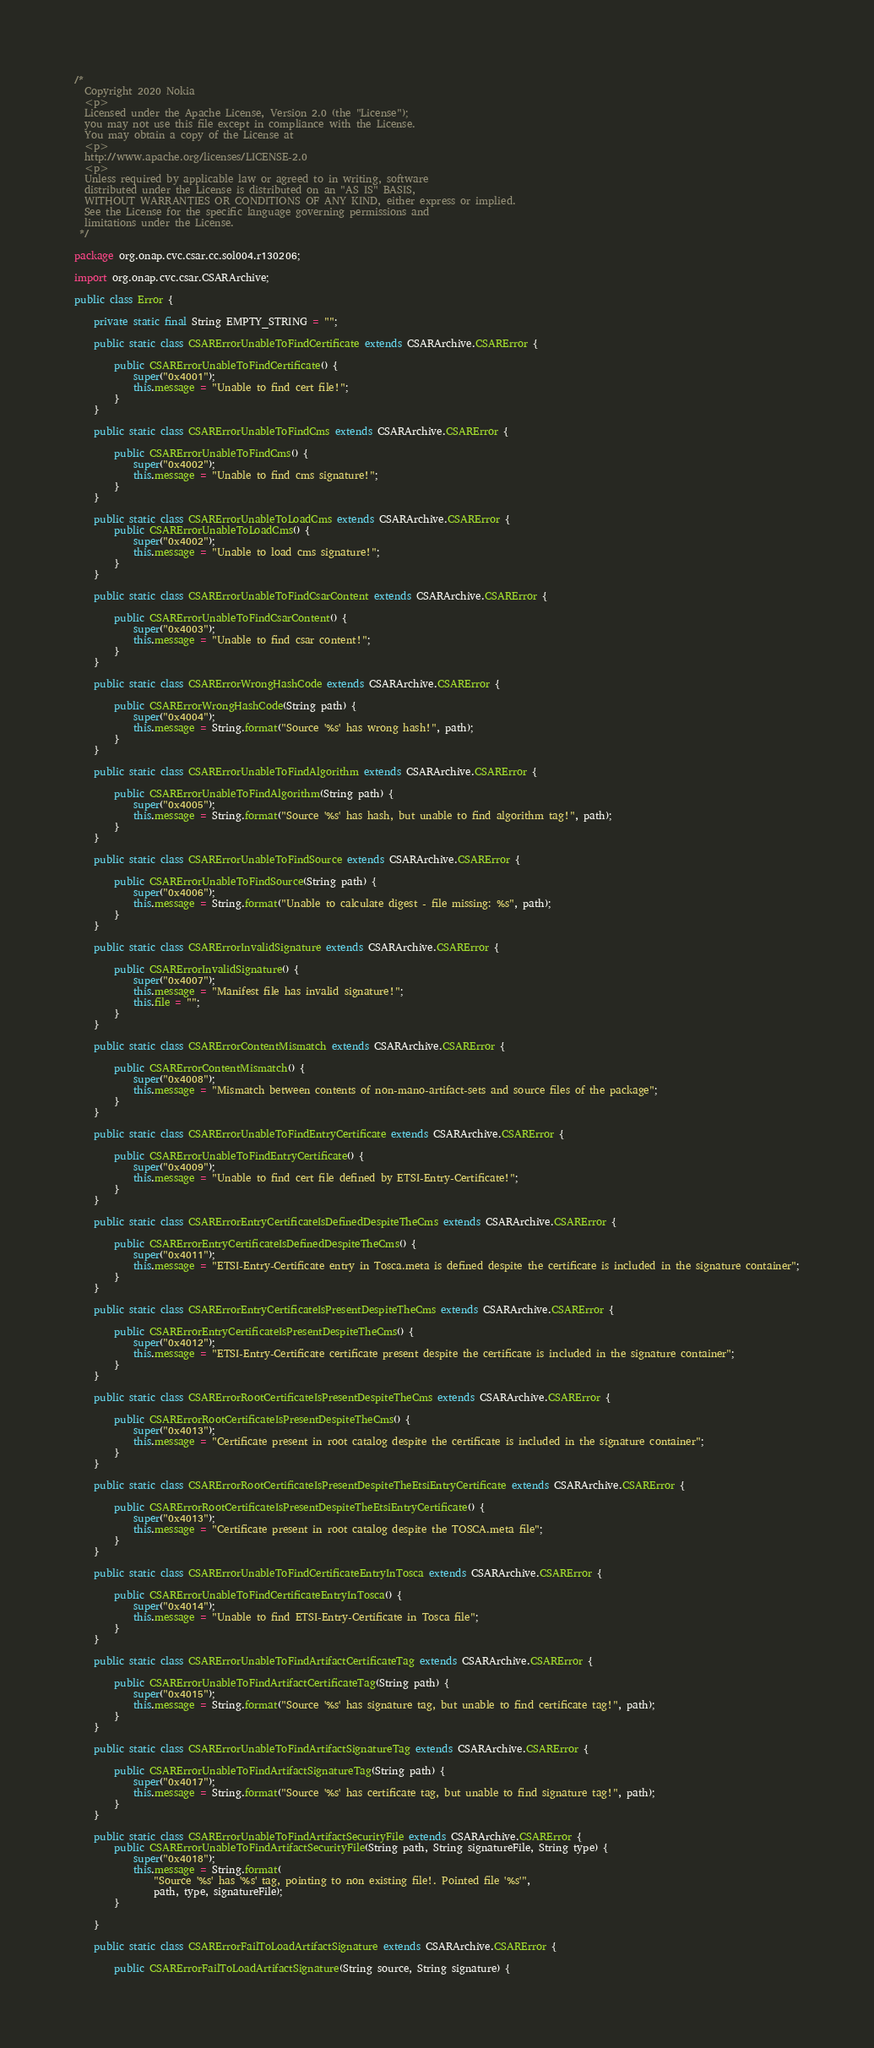<code> <loc_0><loc_0><loc_500><loc_500><_Java_>/*
  Copyright 2020 Nokia
  <p>
  Licensed under the Apache License, Version 2.0 (the "License");
  you may not use this file except in compliance with the License.
  You may obtain a copy of the License at
  <p>
  http://www.apache.org/licenses/LICENSE-2.0
  <p>
  Unless required by applicable law or agreed to in writing, software
  distributed under the License is distributed on an "AS IS" BASIS,
  WITHOUT WARRANTIES OR CONDITIONS OF ANY KIND, either express or implied.
  See the License for the specific language governing permissions and
  limitations under the License.
 */

package org.onap.cvc.csar.cc.sol004.r130206;

import org.onap.cvc.csar.CSARArchive;

public class Error {

    private static final String EMPTY_STRING = "";

    public static class CSARErrorUnableToFindCertificate extends CSARArchive.CSARError {

        public CSARErrorUnableToFindCertificate() {
            super("0x4001");
            this.message = "Unable to find cert file!";
        }
    }

    public static class CSARErrorUnableToFindCms extends CSARArchive.CSARError {

        public CSARErrorUnableToFindCms() {
            super("0x4002");
            this.message = "Unable to find cms signature!";
        }
    }

    public static class CSARErrorUnableToLoadCms extends CSARArchive.CSARError {
        public CSARErrorUnableToLoadCms() {
            super("0x4002");
            this.message = "Unable to load cms signature!";
        }
    }

    public static class CSARErrorUnableToFindCsarContent extends CSARArchive.CSARError {

        public CSARErrorUnableToFindCsarContent() {
            super("0x4003");
            this.message = "Unable to find csar content!";
        }
    }

    public static class CSARErrorWrongHashCode extends CSARArchive.CSARError {

        public CSARErrorWrongHashCode(String path) {
            super("0x4004");
            this.message = String.format("Source '%s' has wrong hash!", path);
        }
    }

    public static class CSARErrorUnableToFindAlgorithm extends CSARArchive.CSARError {

        public CSARErrorUnableToFindAlgorithm(String path) {
            super("0x4005");
            this.message = String.format("Source '%s' has hash, but unable to find algorithm tag!", path);
        }
    }

    public static class CSARErrorUnableToFindSource extends CSARArchive.CSARError {

        public CSARErrorUnableToFindSource(String path) {
            super("0x4006");
            this.message = String.format("Unable to calculate digest - file missing: %s", path);
        }
    }

    public static class CSARErrorInvalidSignature extends CSARArchive.CSARError {

        public CSARErrorInvalidSignature() {
            super("0x4007");
            this.message = "Manifest file has invalid signature!";
            this.file = "";
        }
    }

    public static class CSARErrorContentMismatch extends CSARArchive.CSARError {

        public CSARErrorContentMismatch() {
            super("0x4008");
            this.message = "Mismatch between contents of non-mano-artifact-sets and source files of the package";
        }
    }

    public static class CSARErrorUnableToFindEntryCertificate extends CSARArchive.CSARError {

        public CSARErrorUnableToFindEntryCertificate() {
            super("0x4009");
            this.message = "Unable to find cert file defined by ETSI-Entry-Certificate!";
        }
    }

    public static class CSARErrorEntryCertificateIsDefinedDespiteTheCms extends CSARArchive.CSARError {

        public CSARErrorEntryCertificateIsDefinedDespiteTheCms() {
            super("0x4011");
            this.message = "ETSI-Entry-Certificate entry in Tosca.meta is defined despite the certificate is included in the signature container";
        }
    }

    public static class CSARErrorEntryCertificateIsPresentDespiteTheCms extends CSARArchive.CSARError {

        public CSARErrorEntryCertificateIsPresentDespiteTheCms() {
            super("0x4012");
            this.message = "ETSI-Entry-Certificate certificate present despite the certificate is included in the signature container";
        }
    }

    public static class CSARErrorRootCertificateIsPresentDespiteTheCms extends CSARArchive.CSARError {

        public CSARErrorRootCertificateIsPresentDespiteTheCms() {
            super("0x4013");
            this.message = "Certificate present in root catalog despite the certificate is included in the signature container";
        }
    }

    public static class CSARErrorRootCertificateIsPresentDespiteTheEtsiEntryCertificate extends CSARArchive.CSARError {

        public CSARErrorRootCertificateIsPresentDespiteTheEtsiEntryCertificate() {
            super("0x4013");
            this.message = "Certificate present in root catalog despite the TOSCA.meta file";
        }
    }

    public static class CSARErrorUnableToFindCertificateEntryInTosca extends CSARArchive.CSARError {

        public CSARErrorUnableToFindCertificateEntryInTosca() {
            super("0x4014");
            this.message = "Unable to find ETSI-Entry-Certificate in Tosca file";
        }
    }

    public static class CSARErrorUnableToFindArtifactCertificateTag extends CSARArchive.CSARError {

        public CSARErrorUnableToFindArtifactCertificateTag(String path) {
            super("0x4015");
            this.message = String.format("Source '%s' has signature tag, but unable to find certificate tag!", path);
        }
    }

    public static class CSARErrorUnableToFindArtifactSignatureTag extends CSARArchive.CSARError {

        public CSARErrorUnableToFindArtifactSignatureTag(String path) {
            super("0x4017");
            this.message = String.format("Source '%s' has certificate tag, but unable to find signature tag!", path);
        }
    }

    public static class CSARErrorUnableToFindArtifactSecurityFile extends CSARArchive.CSARError {
        public CSARErrorUnableToFindArtifactSecurityFile(String path, String signatureFile, String type) {
            super("0x4018");
            this.message = String.format(
                "Source '%s' has '%s' tag, pointing to non existing file!. Pointed file '%s'",
                path, type, signatureFile);
        }

    }

    public static class CSARErrorFailToLoadArtifactSignature extends CSARArchive.CSARError {

        public CSARErrorFailToLoadArtifactSignature(String source, String signature) {</code> 